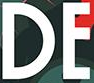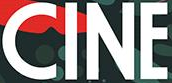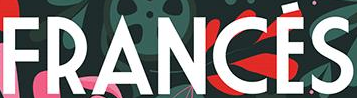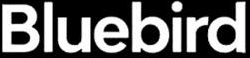What words can you see in these images in sequence, separated by a semicolon? DE; CINE; FRANCÉS; Bluebird 